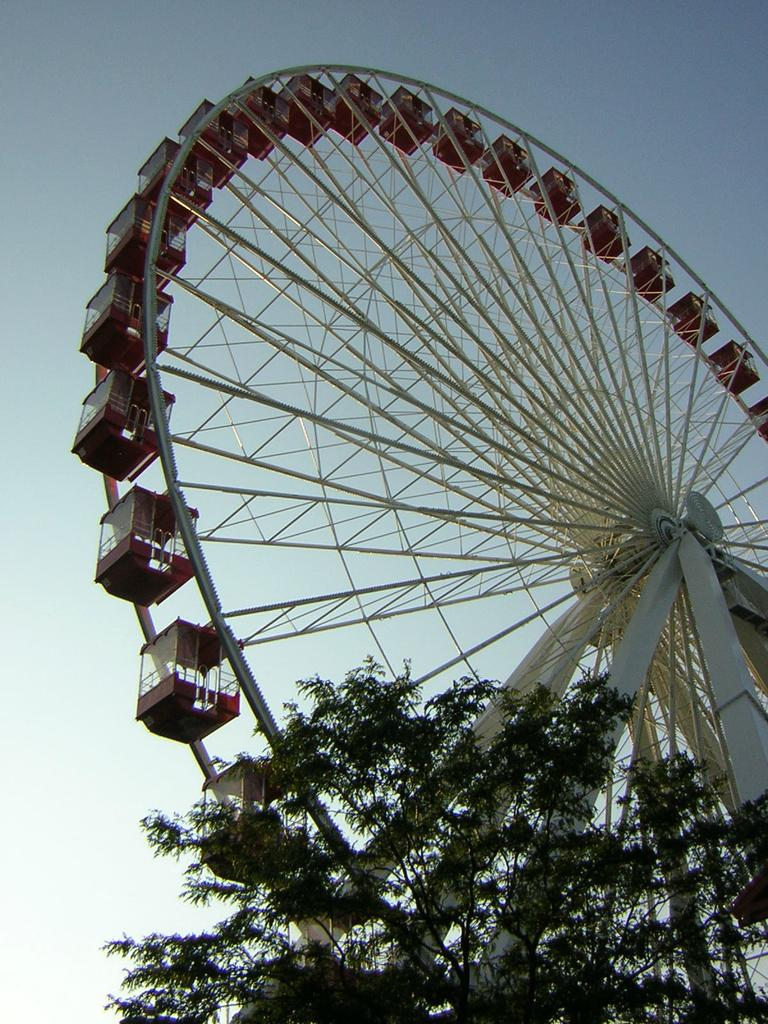What is located at the bottom of the picture? There are leaves at the bottom of the picture. What is the main object in the image? There is a giant wheel in the image. What can be seen in the background of the image? The sky is visible in the background of the image. What type of authority is depicted in the image? There is no authority figure present in the image; it features leaves at the bottom and a giant wheel. How does the mind interact with the giant wheel in the image? There is no mind present in the image, as it is a visual representation of leaves and a giant wheel. 